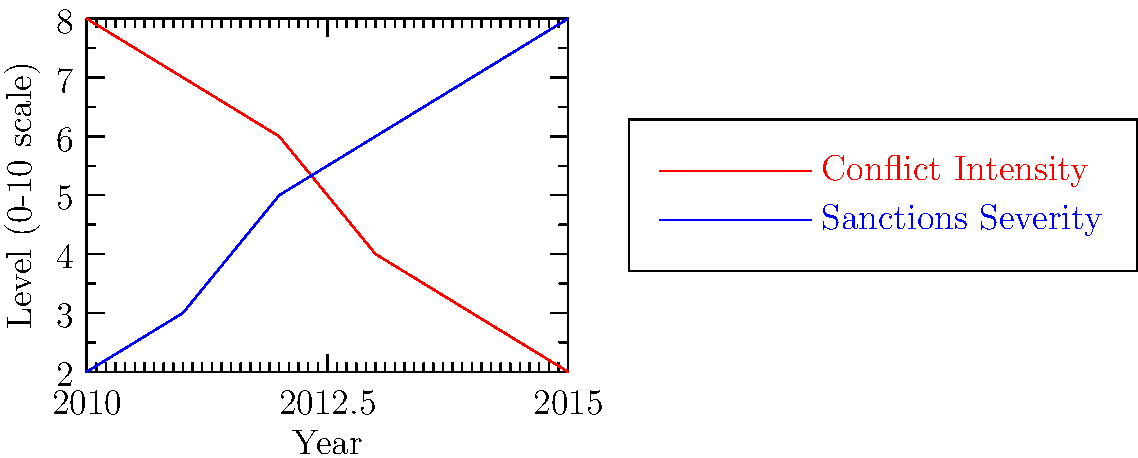Based on the line graph showing the relationship between conflict intensity and sanctions severity over time, what can be inferred about the effectiveness of economic sanctions in resolving the conflict? To answer this question, we need to analyze the trends in both conflict intensity and sanctions severity:

1. Conflict Intensity (red line):
   - Starts high in 2010 at level 8
   - Steadily decreases over time
   - Reaches its lowest point of 2 in 2015

2. Sanctions Severity (blue line):
   - Starts low in 2010 at level 2
   - Steadily increases over time
   - Reaches its highest point of 8 in 2015

3. Relationship between the two variables:
   - As sanctions severity increases, conflict intensity decreases
   - The lines show an inverse relationship

4. Interpretation:
   - The graph suggests a correlation between increased economic sanctions and decreased conflict intensity
   - This implies that economic sanctions may have been effective in reducing the conflict

5. Conclusion:
   - Based on the data presented, economic sanctions appear to have been effective in contributing to the resolution of the conflict
   - However, it's important to note that correlation does not necessarily imply causation, and other factors may have also played a role in the conflict's de-escalation
Answer: Economic sanctions appear effective in conflict resolution, as increased sanctions severity correlates with decreased conflict intensity. 